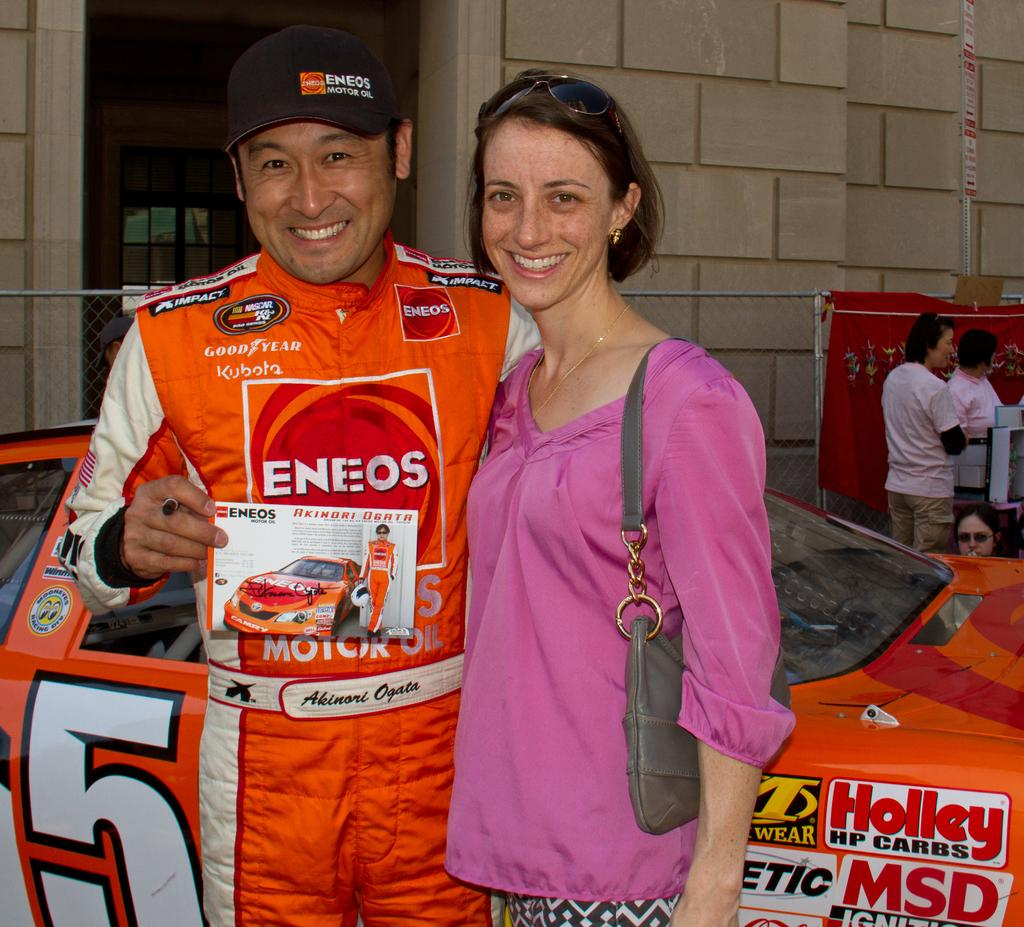Provide a one-sentence caption for the provided image. A woman poses with a race car driver in an orange race suit sponsored by Eneo and Good Year in front of his #5 car. 